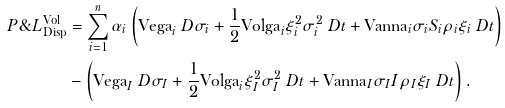Convert formula to latex. <formula><loc_0><loc_0><loc_500><loc_500>P \& L _ { \text {Disp} } ^ { \text {Vol} } & = \sum _ { i = 1 } ^ { n } \alpha _ { i } \left ( \text {Vega} _ { i } \ D \sigma _ { i } + \frac { 1 } { 2 } \text {Volga} _ { i } \xi _ { i } ^ { 2 } \sigma _ { i } ^ { 2 } \ D t + \text {Vanna} _ { i } \sigma _ { i } S _ { i } \rho _ { i } \xi _ { i } \ D t \right ) \\ & - \left ( \text {Vega} _ { I } \ D \sigma _ { I } + \frac { 1 } { 2 } \text {Volga} _ { i } \xi _ { I } ^ { 2 } \sigma _ { I } ^ { 2 } \ D t + \text {Vanna} _ { I } \sigma _ { I } I \rho _ { I } \xi _ { I } \ D t \right ) .</formula> 